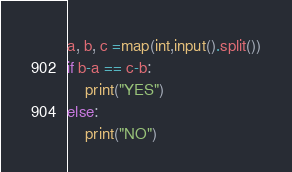Convert code to text. <code><loc_0><loc_0><loc_500><loc_500><_Python_>a, b, c =map(int,input().split())
if b-a == c-b:
    print("YES")
else:
    print("NO")
</code> 